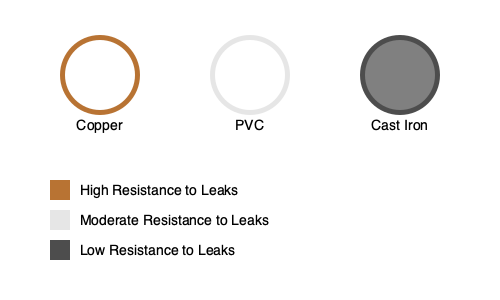Based on the cross-sectional diagrams of different pipe materials shown above, which type of pipe is most susceptible to leaks and why? To determine which type of pipe is most susceptible to leaks, we need to analyze the characteristics of each material shown in the diagram:

1. Copper:
   - Thin-walled structure
   - Uniform material composition
   - Known for durability and corrosion resistance
   - Legend indicates high resistance to leaks

2. PVC (Polyvinyl Chloride):
   - Thicker wall compared to copper
   - Uniform material composition
   - Resistant to corrosion and chemical damage
   - Legend indicates moderate resistance to leaks

3. Cast Iron:
   - Thickest wall among the three
   - Non-uniform internal surface (indicated by darker inner circle)
   - Prone to corrosion and rust formation over time
   - Legend indicates low resistance to leaks

Comparing these characteristics:
- Copper and PVC are more resistant to leaks due to their uniform composition and corrosion resistance.
- Cast iron, despite its thick walls, is more susceptible to leaks because:
  a) It corrodes over time, weakening the pipe structure.
  b) Rust formation can lead to pitting and eventual perforations.
  c) The non-uniform internal surface can accelerate wear and tear.

The legend explicitly states that cast iron has the lowest resistance to leaks among the three materials shown.

Therefore, based on the information provided in the diagram and legend, cast iron pipes are most susceptible to leaks due to their vulnerability to corrosion and subsequent structural weakening over time.
Answer: Cast iron pipes, due to their susceptibility to corrosion and rust formation. 